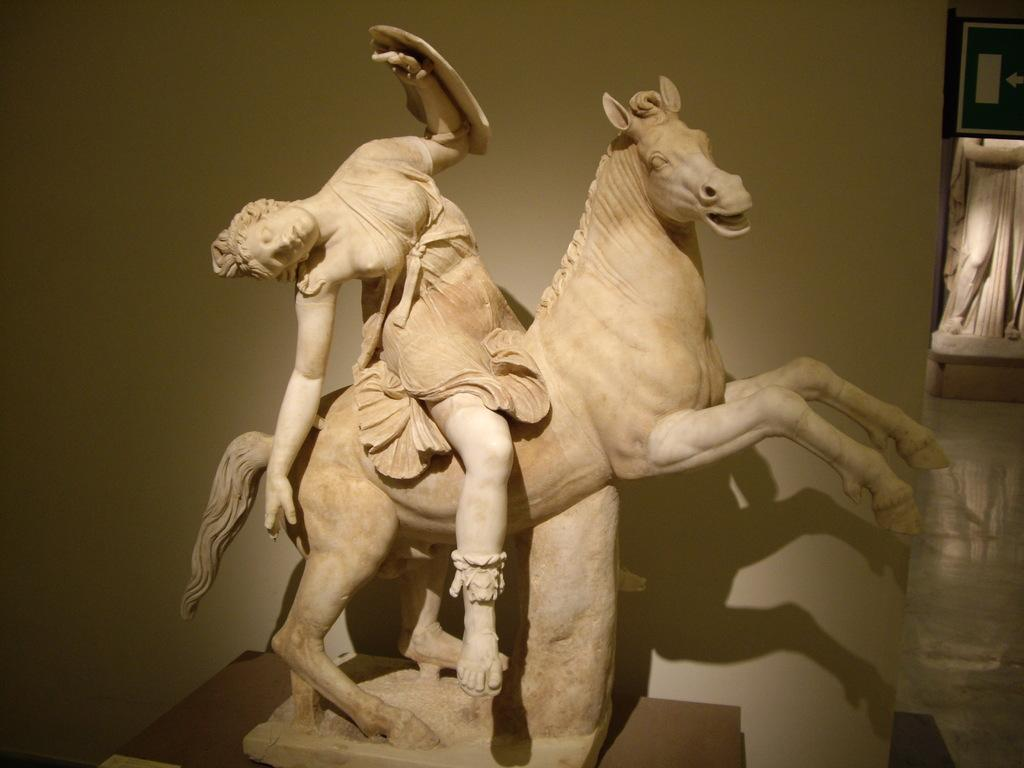What is the main subject of the image? There is a statue of a person sitting on a horse in the image. Are there any other statues in the image? Yes, there is another statue in the image. What type of net is being used to catch the cream in the image? There is no net or cream present in the image; it features two statues. 